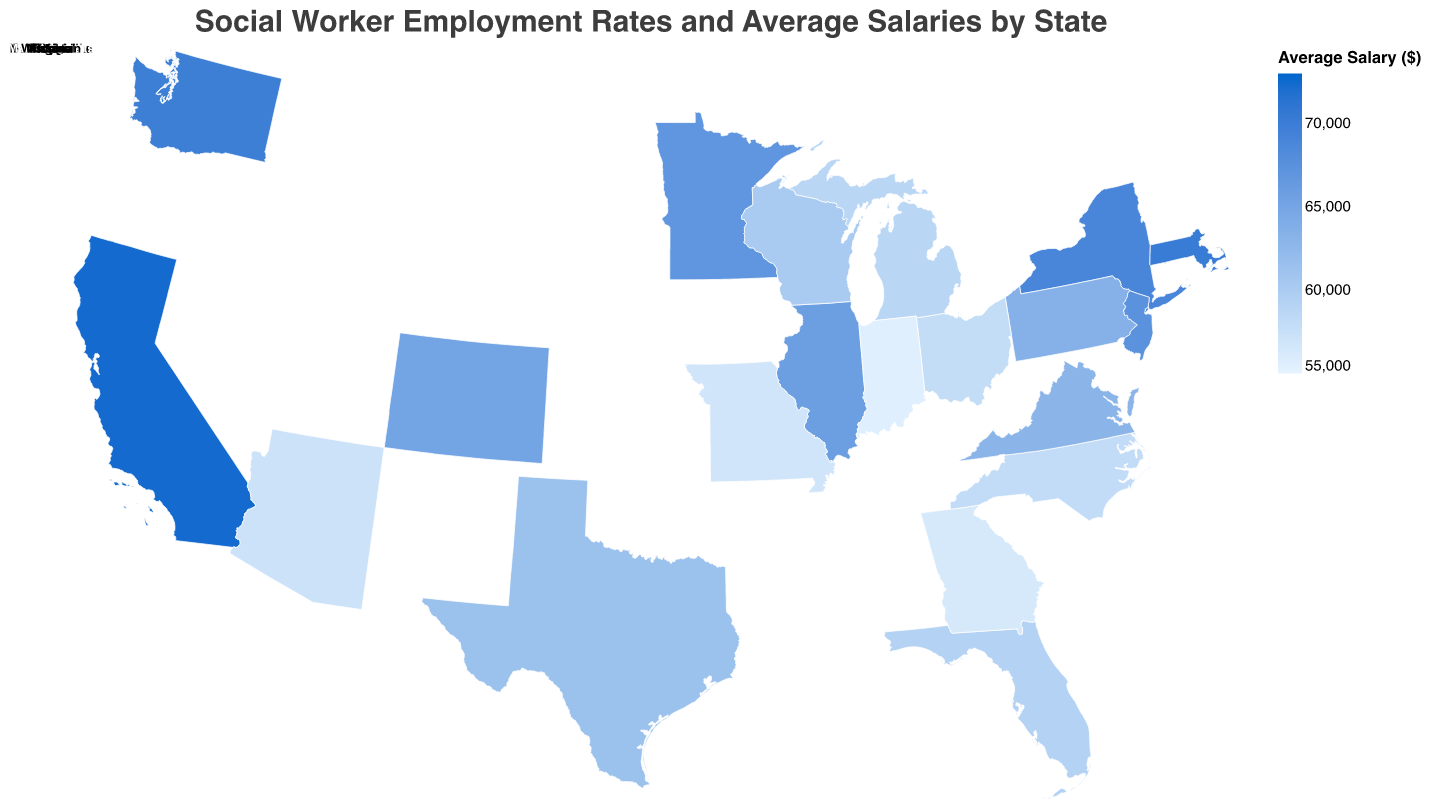Which state has the highest average salary for social workers? Based on the color scale and the data, California has the highest average salary for social workers at $72,450.
Answer: California What is the employment rate of social workers in New York? The tooltip for New York shows an employment rate of 93.8%.
Answer: 93.8% Which state has the lowest employment rate for social workers? By examining the figure and comparing employment rates, Indiana has the lowest employment rate at 86.9%.
Answer: Indiana How does the average salary in Washington compare to that in Texas? The tooltip indicates that Washington has an average salary of $69,870, while Texas has $61,470. Comparing these two, Washington has a higher average salary.
Answer: Washington has a higher salary What is the difference in employment rate between Florida and Virginia? Florida has an employment rate of 89.7%, and Virginia has 91.8%. The difference is 91.8% - 89.7% = 2.1%.
Answer: 2.1% Which states have an average salary above $70,000? By looking at the color scale and the tooltips, California ($72,450) and Massachusetts ($70,230) have average salaries above $70,000.
Answer: California and Massachusetts What is the median employment rate among the states listed? Listing the employment rates in order: 86.9, 87.2, 87.6, 88.1, 88.5, 88.9, 89.4, 89.7, 90.2, 90.6, 91.5, 91.8, 92.3, 92.7, 92.9, 93.2, 93.6, 93.8, 94.1, 95.2. There are 20 values, so the median will be the average of the 10th and 11th values: (90.6 + 91.5) / 2 = 91.05.
Answer: 91.05 Which state has a higher average salary, New Jersey or Minnesota? The tooltip reveals that New Jersey has an average salary of $67,350, and Minnesota has $66,890. Therefore, New Jersey has a higher average salary.
Answer: New Jersey What's the average salary of social workers in the Midwest region (Illinois, Ohio, Michigan, Wisconsin, Minnesota, Missouri, Indiana)? Summing the average salaries: $65,780 (Illinois) + $57,890 (Ohio) + $58,740 (Michigan) + $60,180 (Wisconsin) + $66,890 (Minnesota) + $56,780 (Missouri) + $55,490 (Indiana) = $421,750. Dividing by 7 states, $421,750 / 7 = $60,250.
Answer: $60,250 Which three states have the highest social worker employment rates, and what are those rates? The top three states by employment rate are California (95.2%), Massachusetts (94.1%), and New York (93.8%). This information is derived from the figure and tooltip data.
Answer: California (95.2%), Massachusetts (94.1%), New York (93.8%) 